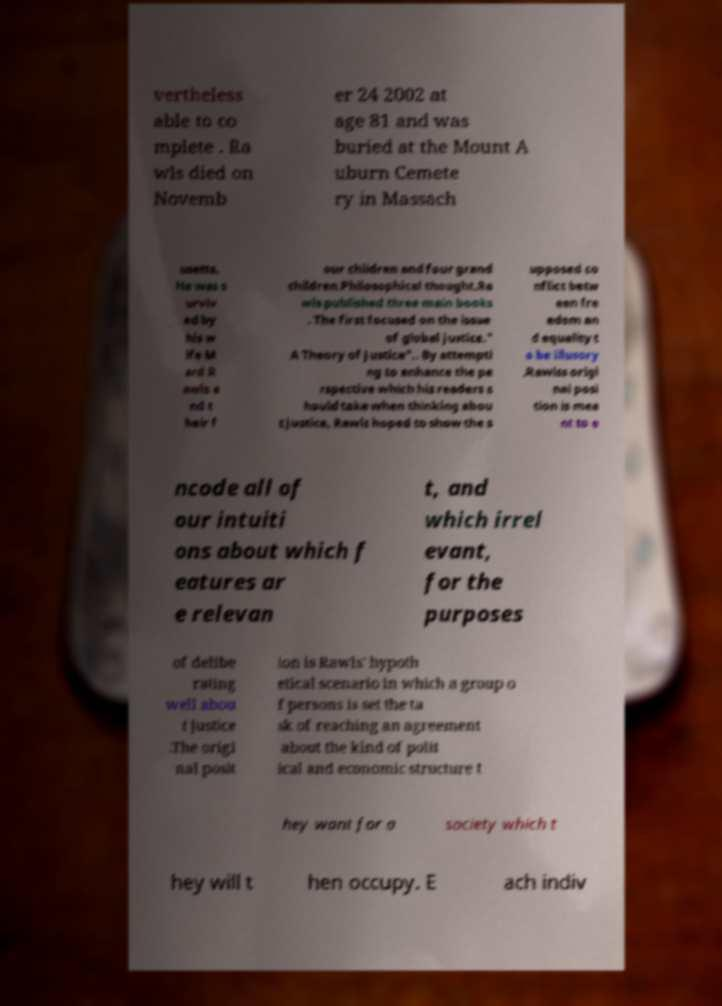For documentation purposes, I need the text within this image transcribed. Could you provide that? vertheless able to co mplete . Ra wls died on Novemb er 24 2002 at age 81 and was buried at the Mount A uburn Cemete ry in Massach usetts. He was s urviv ed by his w ife M ard R awls a nd t heir f our children and four grand children.Philosophical thought.Ra wls published three main books . The first focused on the issue of global justice." A Theory of Justice".. By attempti ng to enhance the pe rspective which his readers s hould take when thinking abou t justice, Rawls hoped to show the s upposed co nflict betw een fre edom an d equality t o be illusory .Rawlss origi nal posi tion is mea nt to e ncode all of our intuiti ons about which f eatures ar e relevan t, and which irrel evant, for the purposes of delibe rating well abou t justice .The origi nal posit ion is Rawls' hypoth etical scenario in which a group o f persons is set the ta sk of reaching an agreement about the kind of polit ical and economic structure t hey want for a society which t hey will t hen occupy. E ach indiv 